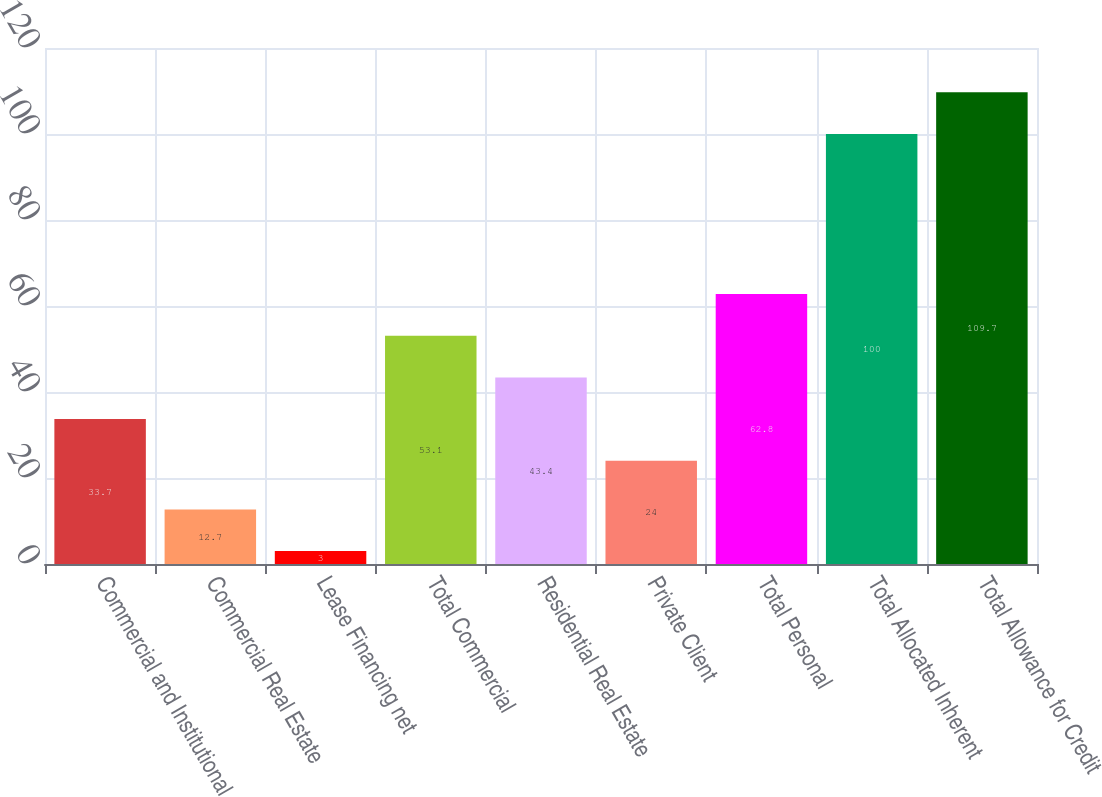Convert chart to OTSL. <chart><loc_0><loc_0><loc_500><loc_500><bar_chart><fcel>Commercial and Institutional<fcel>Commercial Real Estate<fcel>Lease Financing net<fcel>Total Commercial<fcel>Residential Real Estate<fcel>Private Client<fcel>Total Personal<fcel>Total Allocated Inherent<fcel>Total Allowance for Credit<nl><fcel>33.7<fcel>12.7<fcel>3<fcel>53.1<fcel>43.4<fcel>24<fcel>62.8<fcel>100<fcel>109.7<nl></chart> 